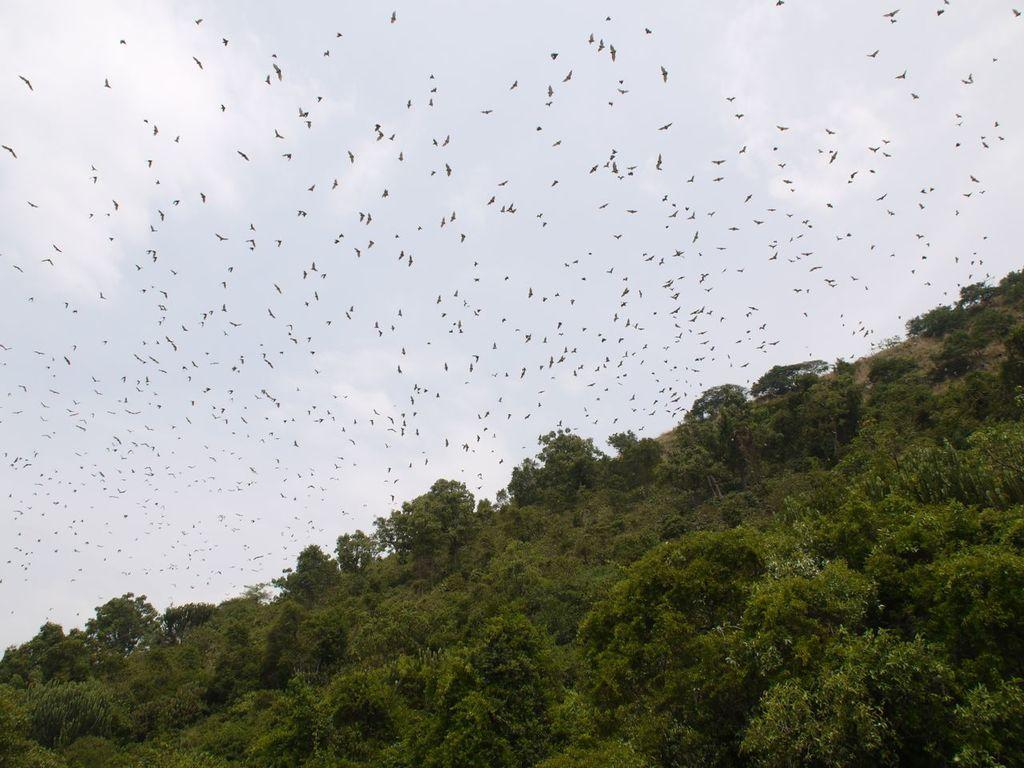What is located at the bottom of the picture? There are many trees at the bottom of the picture. What can be seen at the top of the picture? The sky is visible at the top of the picture. What is happening in the sky? There are birds flying in the sky. What position does the pear hold in the image? There is no pear present in the image. Are the birds playing a game in the sky? The image does not provide information about the birds playing a game; it only shows them flying in the sky. 